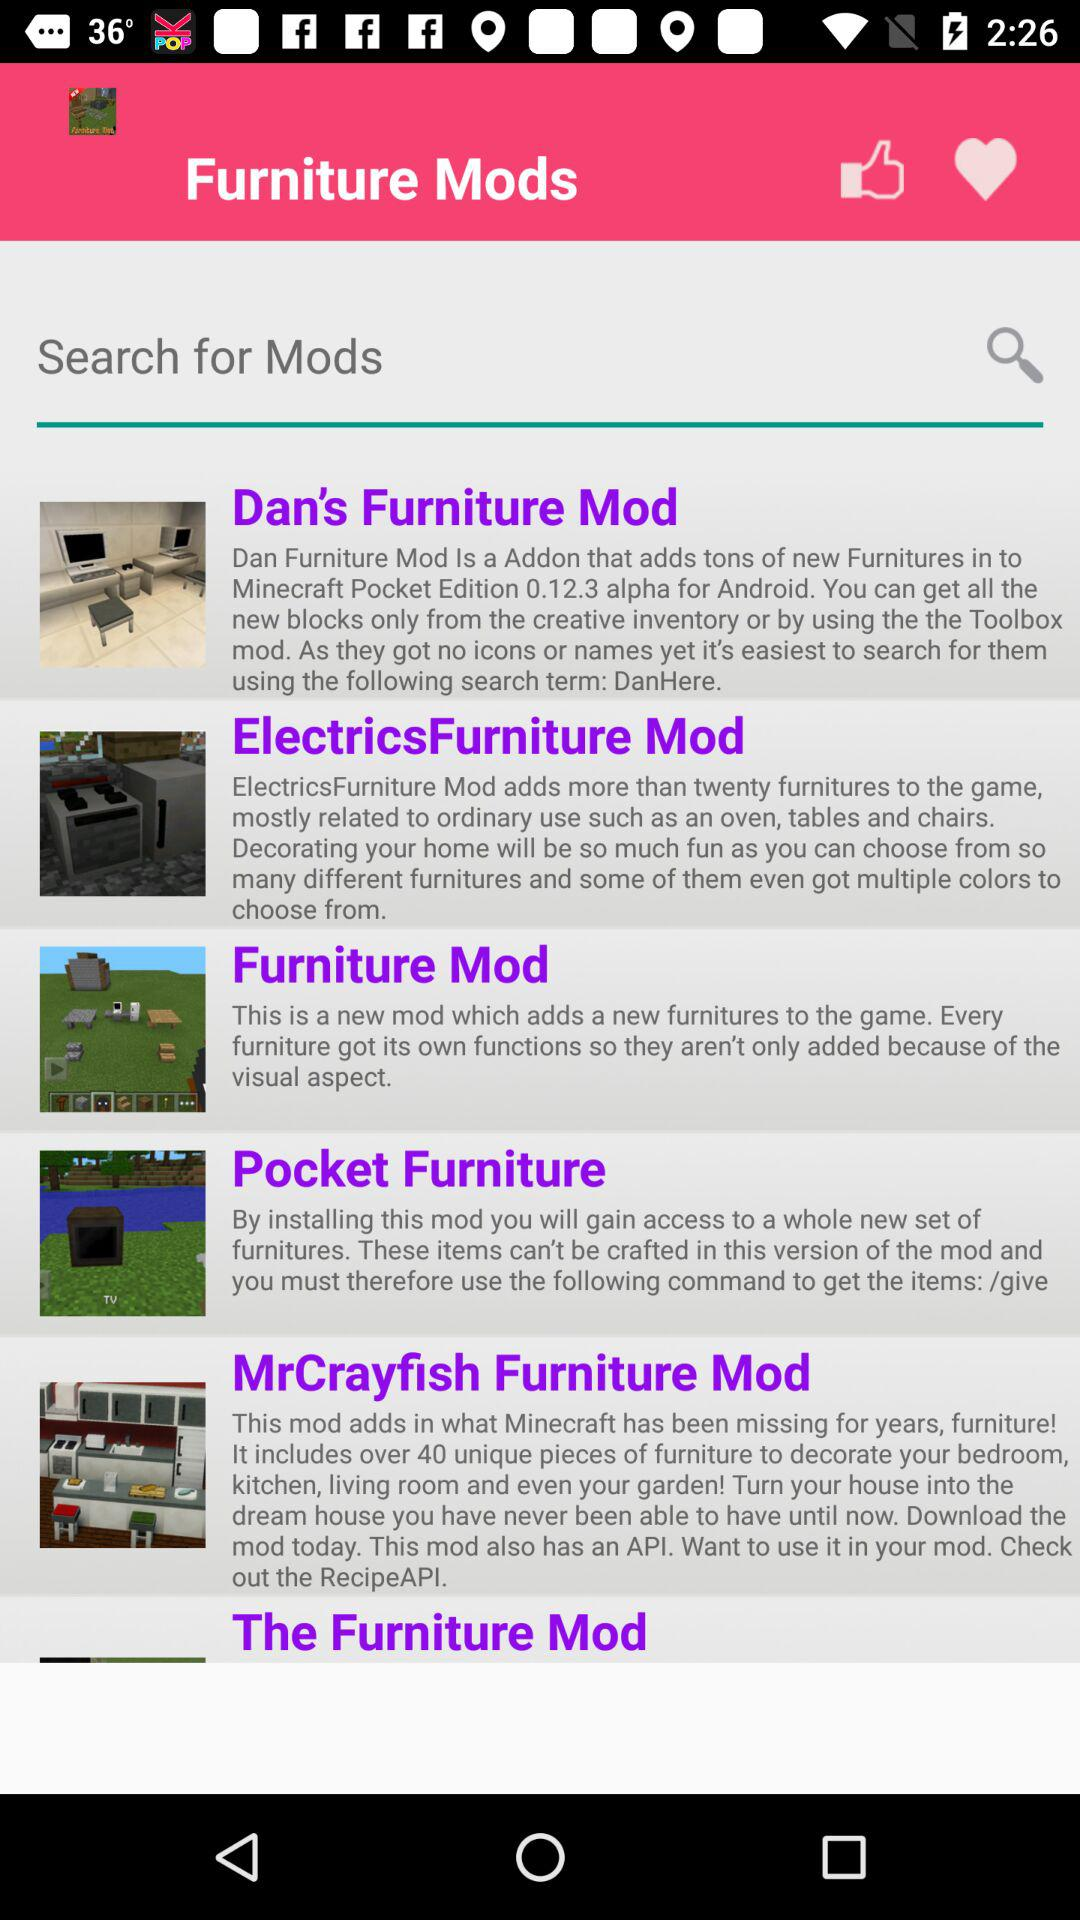From which furniture mod will you gain access to a whole new set of furniture? The furniture mod is "Pocket Furniture". 